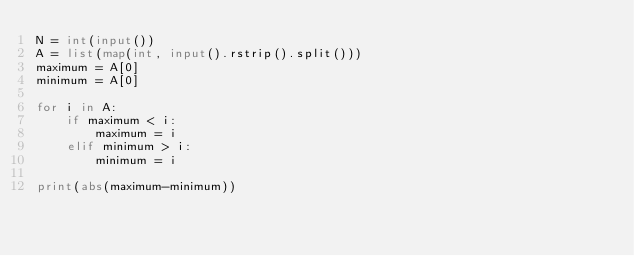<code> <loc_0><loc_0><loc_500><loc_500><_Python_>N = int(input())
A = list(map(int, input().rstrip().split()))
maximum = A[0]
minimum = A[0]

for i in A:
    if maximum < i:
        maximum = i
    elif minimum > i:
        minimum = i

print(abs(maximum-minimum))</code> 